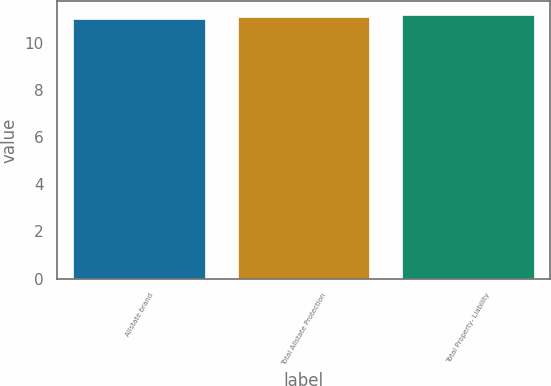Convert chart. <chart><loc_0><loc_0><loc_500><loc_500><bar_chart><fcel>Allstate brand<fcel>Total Allstate Protection<fcel>Total Property- Liability<nl><fcel>11<fcel>11.1<fcel>11.2<nl></chart> 